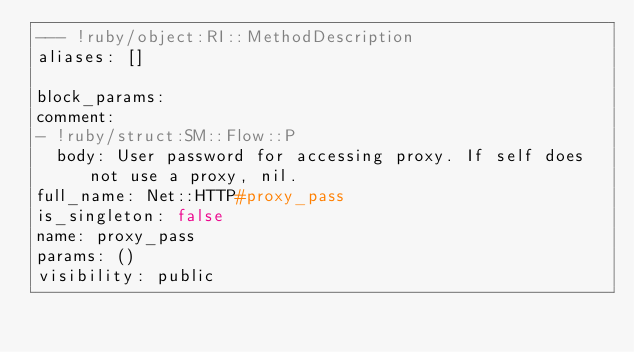Convert code to text. <code><loc_0><loc_0><loc_500><loc_500><_YAML_>--- !ruby/object:RI::MethodDescription 
aliases: []

block_params: 
comment: 
- !ruby/struct:SM::Flow::P 
  body: User password for accessing proxy. If self does not use a proxy, nil.
full_name: Net::HTTP#proxy_pass
is_singleton: false
name: proxy_pass
params: ()
visibility: public
</code> 